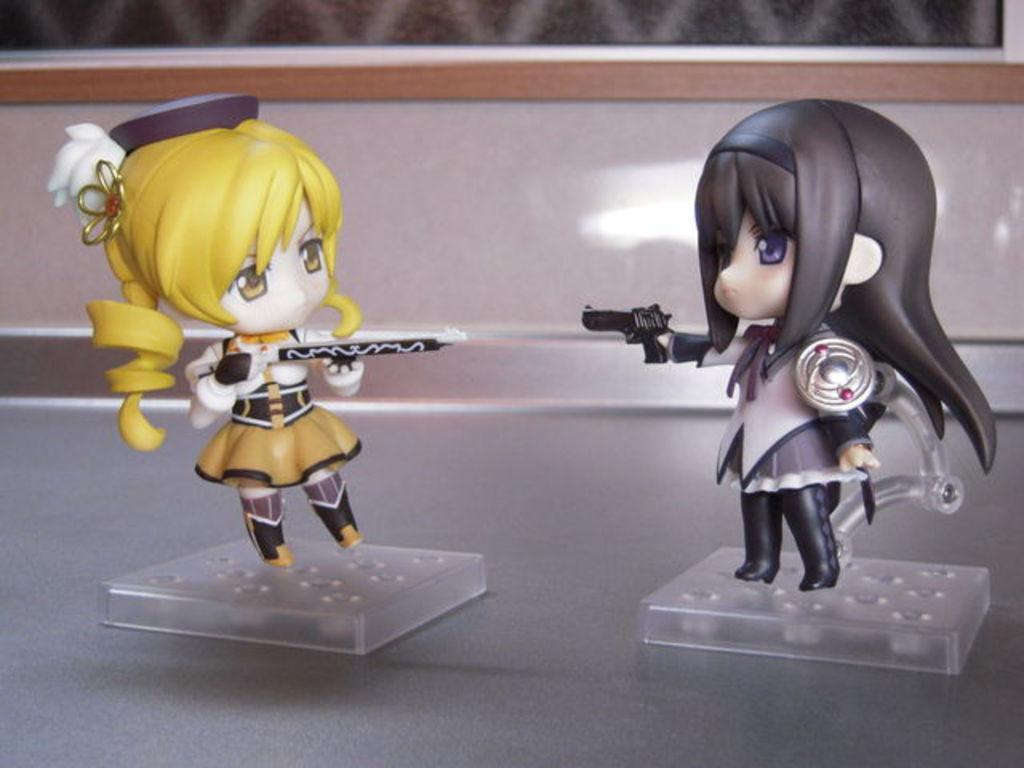What type of objects are in the image? There are two cartoon doll toys in the image. How are the dolls positioned in the image? The dolls are standing in front of the image. Where are the dolls placed? The dolls are placed on a tabletop. What can be seen in the background of the image? There is a brown color wooden wall in the background of the image. What type of garden can be seen in the image? There is no garden present in the image; it features two cartoon doll toys placed on a tabletop in front of a brown color wooden wall. 